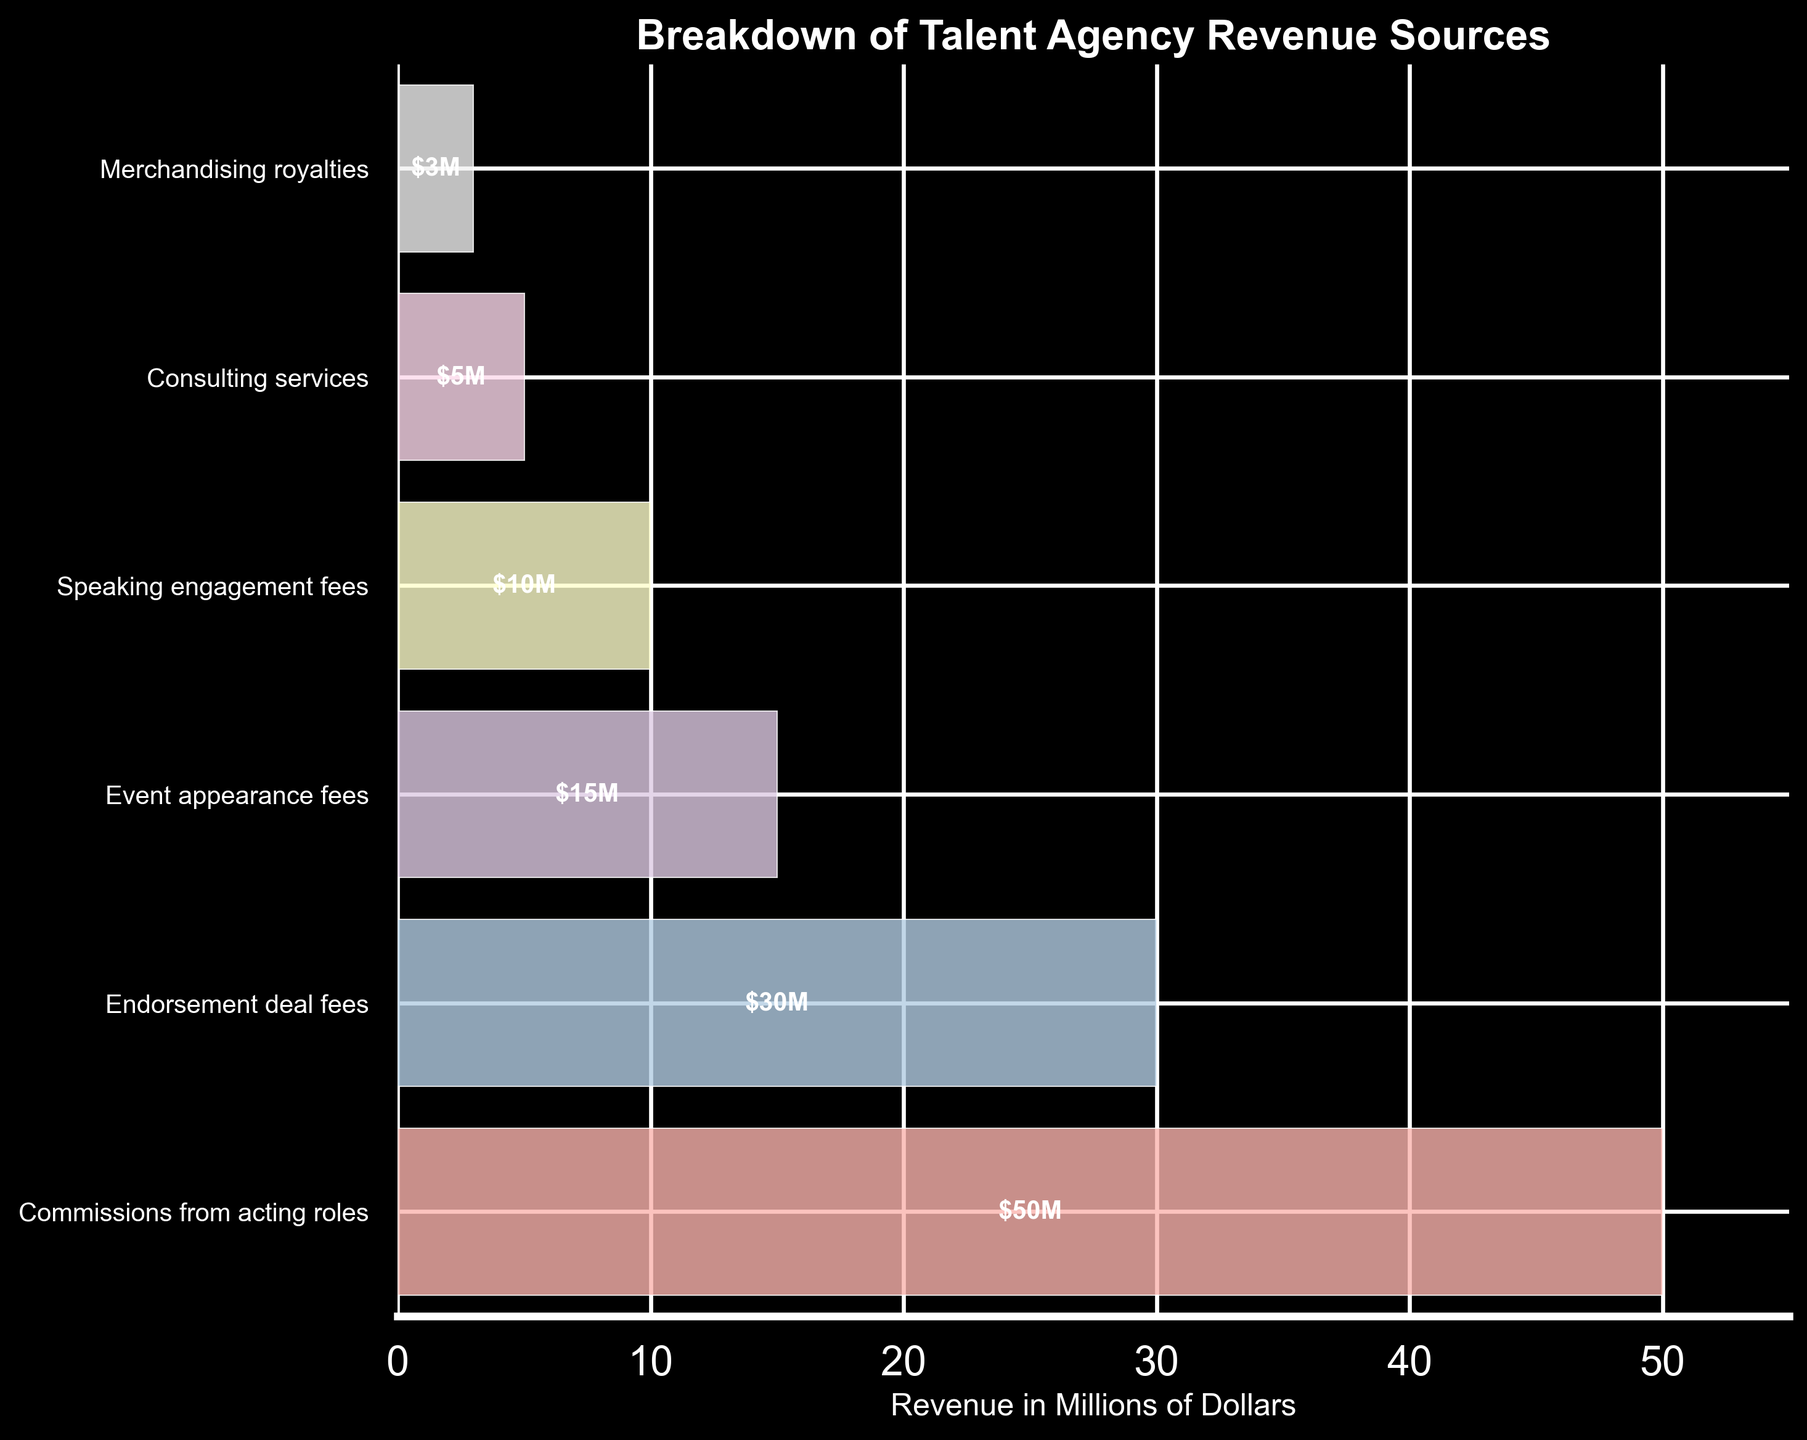What is the title of the chart? Look at the top of the chart where the title is typically located. The title provides a summary of the chart's content.
Answer: Breakdown of Talent Agency Revenue Sources Which revenue source has the highest value? Look at the chart and identify the largest segment. The width of the segment represents the magnitude of the revenue.
Answer: Commissions from acting roles How much revenue do endorsement deal fees generate? Find the segment labeled "Endorsement deal fees" and read the value provided within this segment.
Answer: $30M What is the total revenue from all sources combined? Add up the individual revenue amounts: $50M + $30M + $15M + $10M + $5M + $3M.
Answer: $113M How does the revenue from event appearance fees compare to speaking engagement fees? Compare the segments labeled "Event appearance fees" and "Speaking engagement fees" to see which is larger. Subtract the smaller value from the larger value if needed.
Answer: Event appearance fees are $5M higher than speaking engagement fees What is the smallest revenue source? Identify the segment that has the smallest width in the chart.
Answer: Merchandising royalties What percentage of total revenue comes from commissions from acting roles? Divide the revenue from commissions from acting roles ($50M) by the total revenue ($113M), and then multiply by 100 to convert to a percentage.
Answer: 44.25% If the revenue from consulting services doubled, what would the new total revenue be? Double the consulting services revenue: $5M * 2 = $10M. Add this new value to the sum of the other revenue sources (without the original consulting services amount): $50M + $30M + $15M + $10M + $3M + $10M.
Answer: $118M Which two revenue sources together make up the same amount of revenue as endorsement deal fees? Try different combinations of two revenue sources to see which ones add up to $30M. The relevant pairs are: Merchandising royalties + Consulting services ($3M + $5M = $8M), Event appearance fees + Speaking engagement fees ($15M + $10M = $25M) and another possible pair from remaining combination.
Answer: There is no such pair that adds up to $30M 